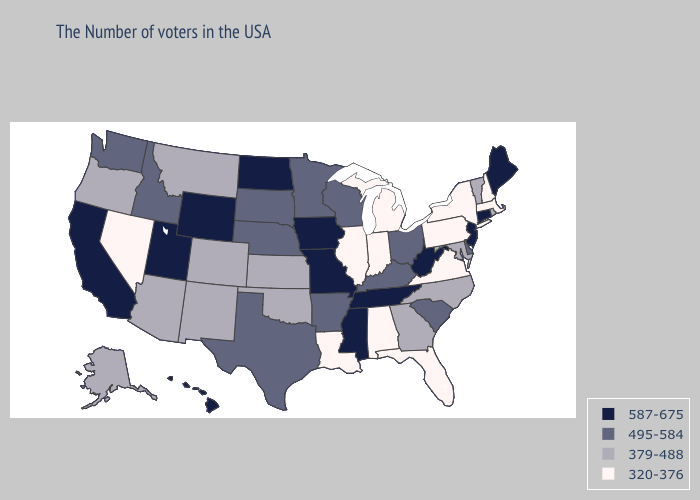Name the states that have a value in the range 587-675?
Concise answer only. Maine, Connecticut, New Jersey, West Virginia, Tennessee, Mississippi, Missouri, Iowa, North Dakota, Wyoming, Utah, California, Hawaii. Does Pennsylvania have the highest value in the Northeast?
Answer briefly. No. What is the value of Tennessee?
Concise answer only. 587-675. What is the value of Missouri?
Write a very short answer. 587-675. Does Florida have the lowest value in the South?
Short answer required. Yes. Does Tennessee have the highest value in the South?
Be succinct. Yes. Name the states that have a value in the range 379-488?
Quick response, please. Rhode Island, Vermont, Maryland, North Carolina, Georgia, Kansas, Oklahoma, Colorado, New Mexico, Montana, Arizona, Oregon, Alaska. Which states have the lowest value in the USA?
Keep it brief. Massachusetts, New Hampshire, New York, Pennsylvania, Virginia, Florida, Michigan, Indiana, Alabama, Illinois, Louisiana, Nevada. Name the states that have a value in the range 320-376?
Keep it brief. Massachusetts, New Hampshire, New York, Pennsylvania, Virginia, Florida, Michigan, Indiana, Alabama, Illinois, Louisiana, Nevada. Which states have the lowest value in the USA?
Keep it brief. Massachusetts, New Hampshire, New York, Pennsylvania, Virginia, Florida, Michigan, Indiana, Alabama, Illinois, Louisiana, Nevada. What is the lowest value in the South?
Quick response, please. 320-376. Which states have the lowest value in the USA?
Give a very brief answer. Massachusetts, New Hampshire, New York, Pennsylvania, Virginia, Florida, Michigan, Indiana, Alabama, Illinois, Louisiana, Nevada. What is the value of Illinois?
Be succinct. 320-376. What is the highest value in the Northeast ?
Concise answer only. 587-675. Does Vermont have the highest value in the Northeast?
Quick response, please. No. 